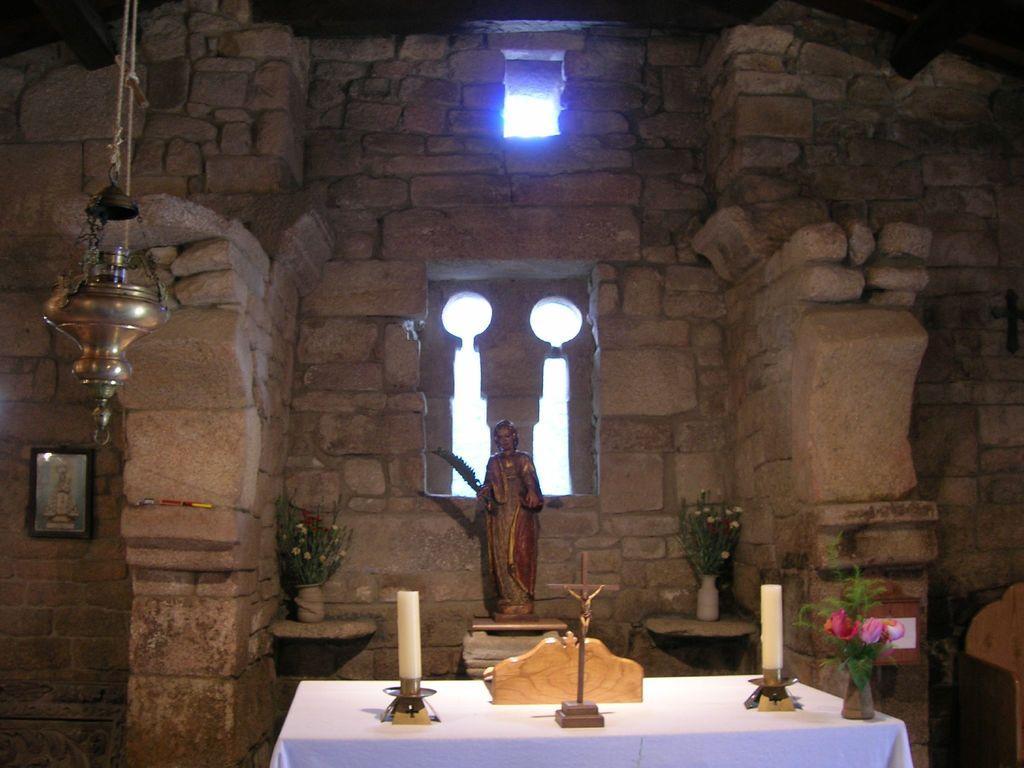Can you describe this image briefly? In this picture I can see inside of the building, there are some sculpture, flower pots, table with white cloth. 